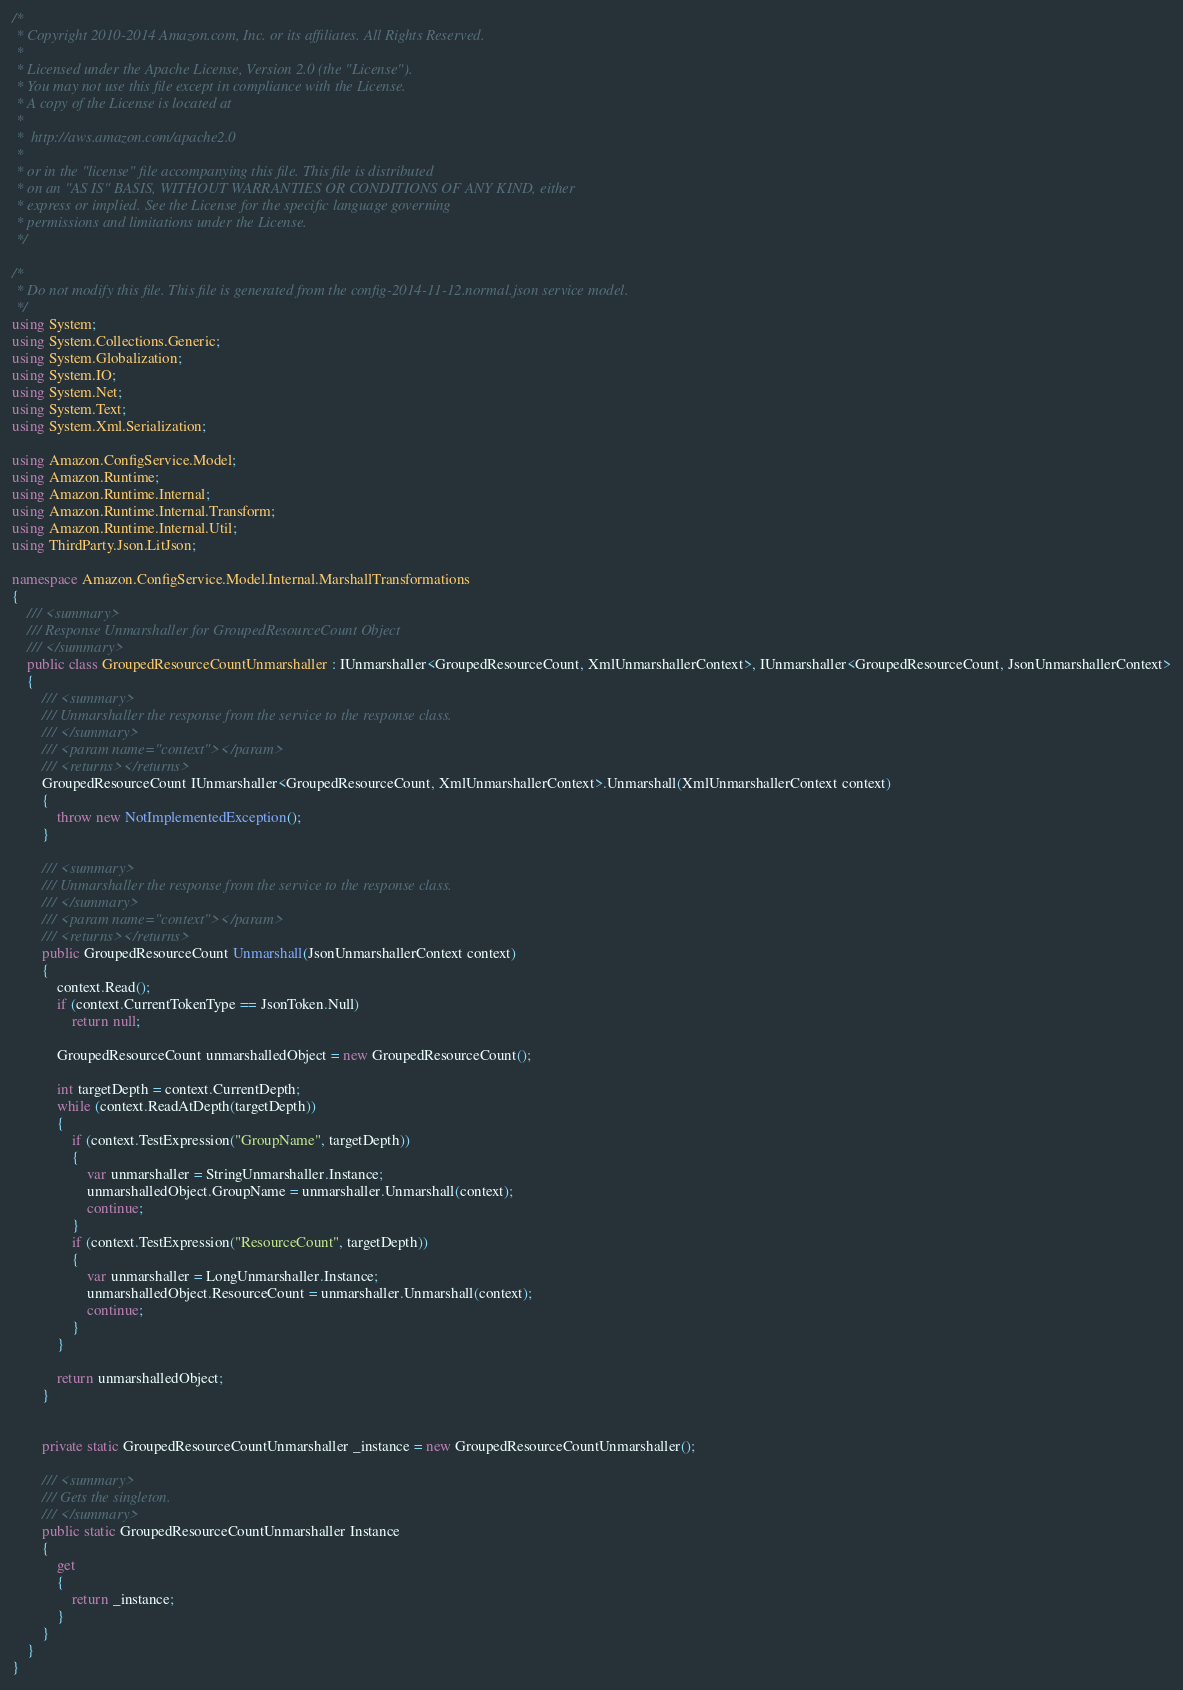<code> <loc_0><loc_0><loc_500><loc_500><_C#_>/*
 * Copyright 2010-2014 Amazon.com, Inc. or its affiliates. All Rights Reserved.
 * 
 * Licensed under the Apache License, Version 2.0 (the "License").
 * You may not use this file except in compliance with the License.
 * A copy of the License is located at
 * 
 *  http://aws.amazon.com/apache2.0
 * 
 * or in the "license" file accompanying this file. This file is distributed
 * on an "AS IS" BASIS, WITHOUT WARRANTIES OR CONDITIONS OF ANY KIND, either
 * express or implied. See the License for the specific language governing
 * permissions and limitations under the License.
 */

/*
 * Do not modify this file. This file is generated from the config-2014-11-12.normal.json service model.
 */
using System;
using System.Collections.Generic;
using System.Globalization;
using System.IO;
using System.Net;
using System.Text;
using System.Xml.Serialization;

using Amazon.ConfigService.Model;
using Amazon.Runtime;
using Amazon.Runtime.Internal;
using Amazon.Runtime.Internal.Transform;
using Amazon.Runtime.Internal.Util;
using ThirdParty.Json.LitJson;

namespace Amazon.ConfigService.Model.Internal.MarshallTransformations
{
    /// <summary>
    /// Response Unmarshaller for GroupedResourceCount Object
    /// </summary>  
    public class GroupedResourceCountUnmarshaller : IUnmarshaller<GroupedResourceCount, XmlUnmarshallerContext>, IUnmarshaller<GroupedResourceCount, JsonUnmarshallerContext>
    {
        /// <summary>
        /// Unmarshaller the response from the service to the response class.
        /// </summary>  
        /// <param name="context"></param>
        /// <returns></returns>
        GroupedResourceCount IUnmarshaller<GroupedResourceCount, XmlUnmarshallerContext>.Unmarshall(XmlUnmarshallerContext context)
        {
            throw new NotImplementedException();
        }

        /// <summary>
        /// Unmarshaller the response from the service to the response class.
        /// </summary>  
        /// <param name="context"></param>
        /// <returns></returns>
        public GroupedResourceCount Unmarshall(JsonUnmarshallerContext context)
        {
            context.Read();
            if (context.CurrentTokenType == JsonToken.Null) 
                return null;

            GroupedResourceCount unmarshalledObject = new GroupedResourceCount();
        
            int targetDepth = context.CurrentDepth;
            while (context.ReadAtDepth(targetDepth))
            {
                if (context.TestExpression("GroupName", targetDepth))
                {
                    var unmarshaller = StringUnmarshaller.Instance;
                    unmarshalledObject.GroupName = unmarshaller.Unmarshall(context);
                    continue;
                }
                if (context.TestExpression("ResourceCount", targetDepth))
                {
                    var unmarshaller = LongUnmarshaller.Instance;
                    unmarshalledObject.ResourceCount = unmarshaller.Unmarshall(context);
                    continue;
                }
            }
          
            return unmarshalledObject;
        }


        private static GroupedResourceCountUnmarshaller _instance = new GroupedResourceCountUnmarshaller();        

        /// <summary>
        /// Gets the singleton.
        /// </summary>  
        public static GroupedResourceCountUnmarshaller Instance
        {
            get
            {
                return _instance;
            }
        }
    }
}</code> 